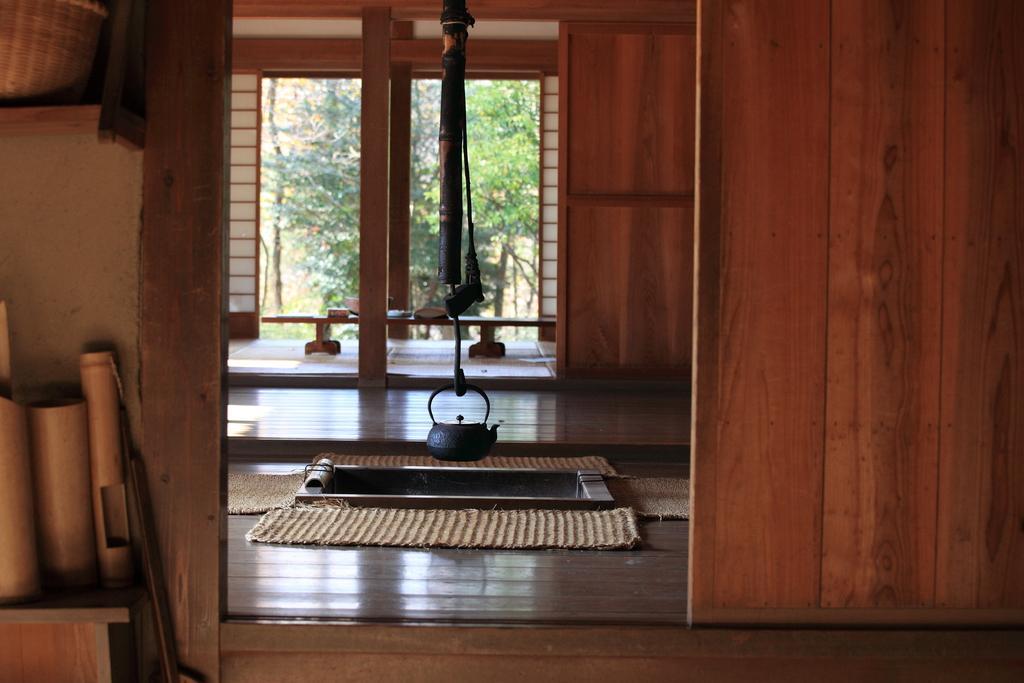Please provide a concise description of this image. In this image I can see the inner part of the house and I can see few wooden objects. Background I can see the wooden wall and the wall is in brown color and I can see trees in green color. In front I can see few mats in cream color. 